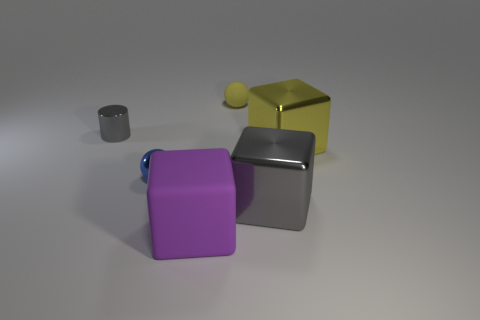What color is the small cylinder?
Offer a very short reply. Gray. What is the material of the gray thing behind the yellow metallic block?
Your response must be concise. Metal. There is a large purple rubber thing; is it the same shape as the gray thing to the right of the big purple block?
Keep it short and to the point. Yes. Are there more purple cubes than gray metal objects?
Provide a short and direct response. No. Is there any other thing that is the same color as the rubber block?
Keep it short and to the point. No. What shape is the large gray thing that is the same material as the gray cylinder?
Your answer should be compact. Cube. There is a tiny sphere that is in front of the tiny shiny object behind the tiny blue metal thing; what is it made of?
Your answer should be very brief. Metal. Do the thing that is behind the small gray thing and the blue shiny object have the same shape?
Your response must be concise. Yes. Is the number of cubes that are left of the shiny cylinder greater than the number of big cyan rubber cylinders?
Your answer should be compact. No. Are there any other things that have the same material as the tiny gray cylinder?
Make the answer very short. Yes. 